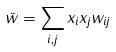Convert formula to latex. <formula><loc_0><loc_0><loc_500><loc_500>\bar { w } = \sum _ { i , j } x _ { i } x _ { j } w _ { i j }</formula> 